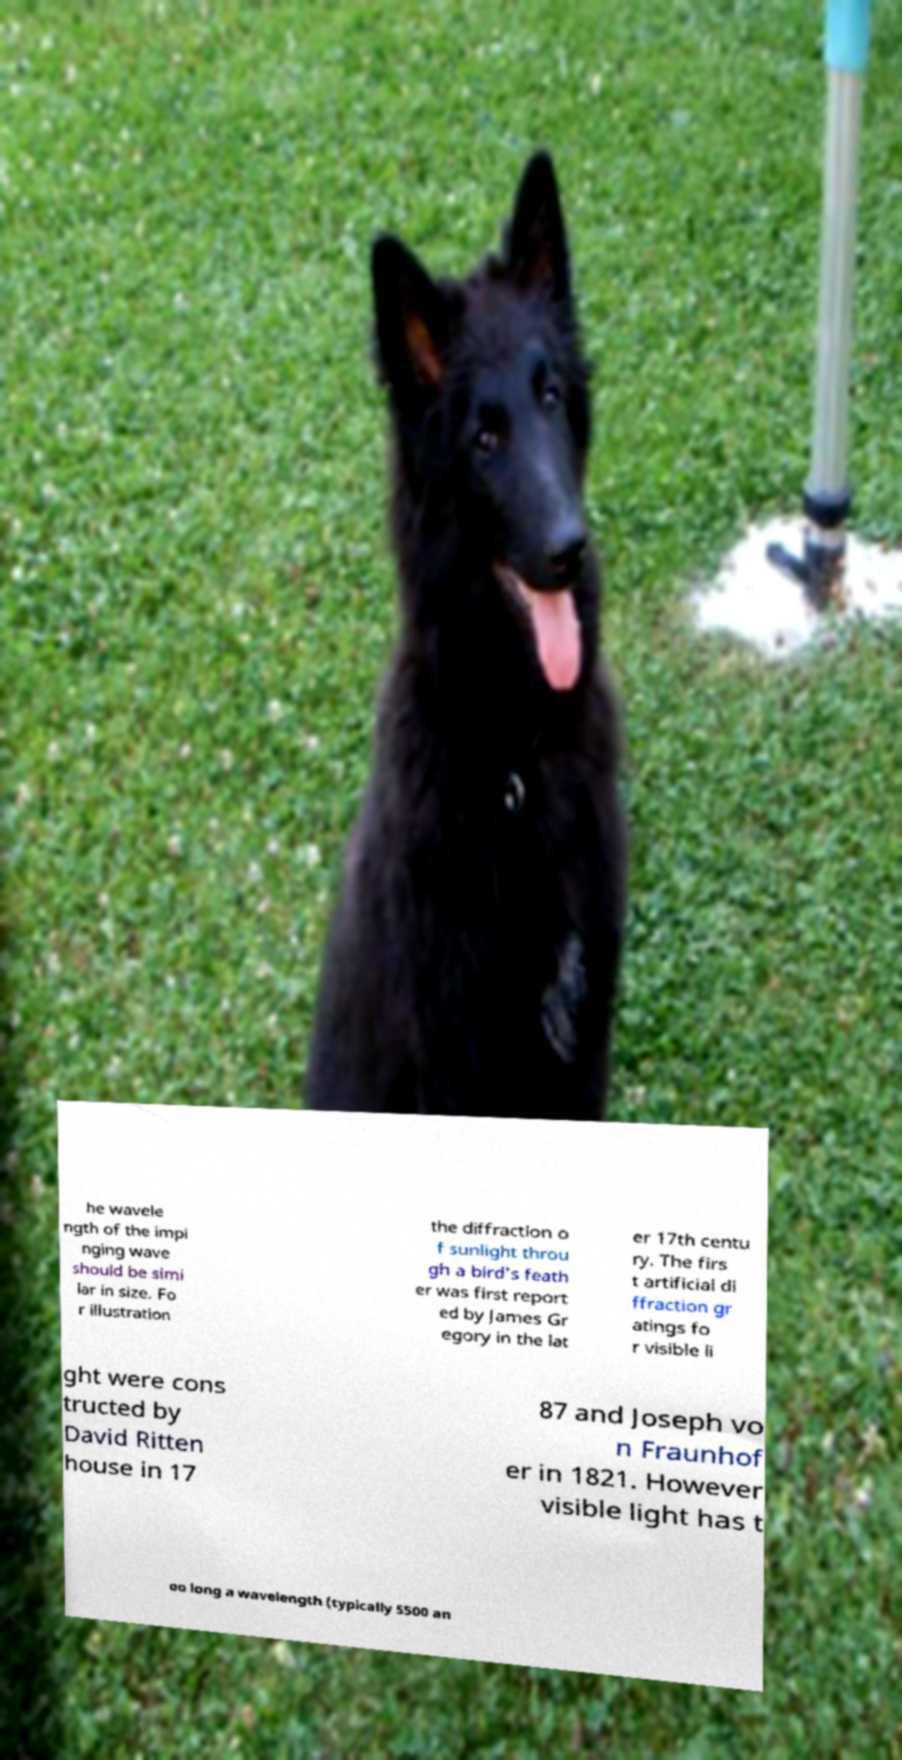Can you accurately transcribe the text from the provided image for me? he wavele ngth of the impi nging wave should be simi lar in size. Fo r illustration the diffraction o f sunlight throu gh a bird's feath er was first report ed by James Gr egory in the lat er 17th centu ry. The firs t artificial di ffraction gr atings fo r visible li ght were cons tructed by David Ritten house in 17 87 and Joseph vo n Fraunhof er in 1821. However visible light has t oo long a wavelength (typically 5500 an 